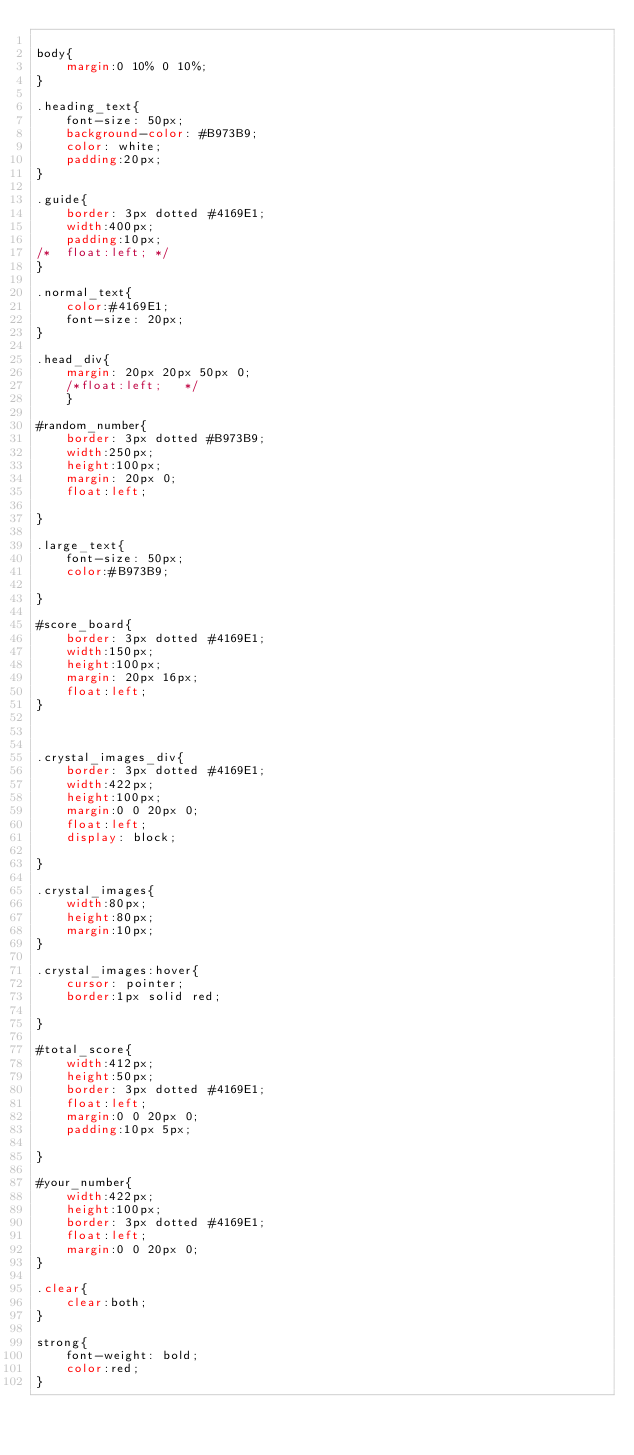Convert code to text. <code><loc_0><loc_0><loc_500><loc_500><_CSS_>
body{
	margin:0 10% 0 10%;
}

.heading_text{
	font-size: 50px;
	background-color: #B973B9;
	color: white;
	padding:20px;
}

.guide{
	border: 3px dotted #4169E1;
	width:400px;
	padding:10px;
/*	float:left;	*/
}

.normal_text{
	color:#4169E1;
	font-size: 20px;		
}

.head_div{
	margin: 20px 20px 50px 0;
	/*float:left;	*/
	}

#random_number{
	border: 3px dotted #B973B9;
	width:250px;
	height:100px;
	margin: 20px 0;	
	float:left;

}

.large_text{
	font-size: 50px;
	color:#B973B9;

}

#score_board{
	border: 3px dotted #4169E1;
	width:150px;
	height:100px;
	margin: 20px 16px;
	float:left;		
}



.crystal_images_div{
	border: 3px dotted #4169E1;
	width:422px;
	height:100px;
	margin:0 0 20px 0;
	float:left;
	display: block;

}

.crystal_images{
	width:80px;
	height:80px;
	margin:10px;
}

.crystal_images:hover{
	cursor: pointer;
	border:1px solid red;

}

#total_score{
	width:412px;
	height:50px;
	border: 3px dotted #4169E1;
	float:left;
	margin:0 0 20px 0;
	padding:10px 5px;

}

#your_number{
	width:422px;
	height:100px;
	border: 3px dotted #4169E1;
	float:left;
	margin:0 0 20px 0;
}

.clear{
	clear:both;
}

strong{
	font-weight: bold;
	color:red;
}</code> 